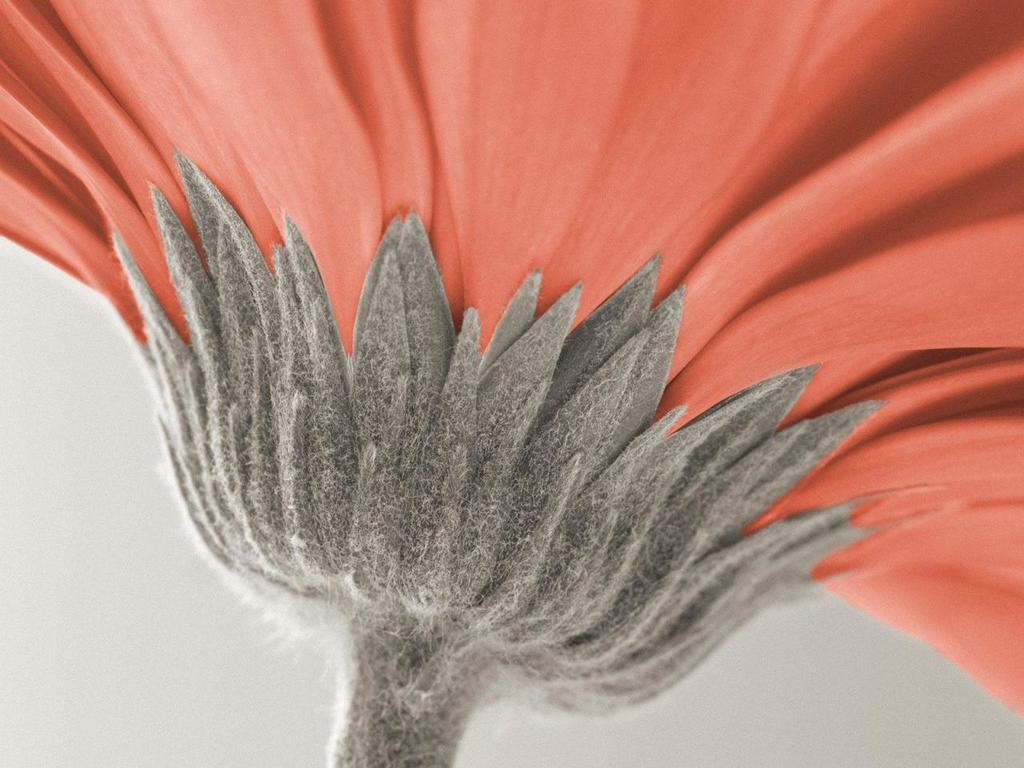What is the main subject of the image? There is a flower in the image. What is the color of the flower? The flower is orange in color. What is the color of the flower's sepals and stem? The sepals and stem of the flower are grey in color. What color is the background of the image? The background of the image is white. Can you see any fangs or blood on the flower in the image? No, there are no fangs or blood present on the flower in the image. 